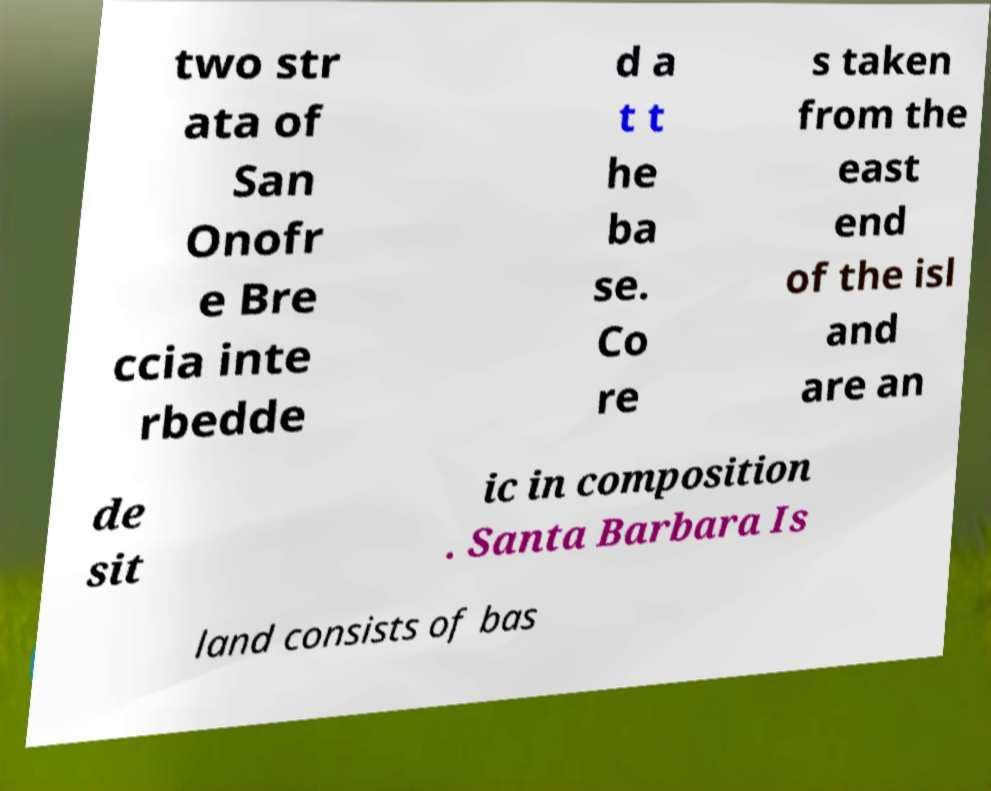For documentation purposes, I need the text within this image transcribed. Could you provide that? two str ata of San Onofr e Bre ccia inte rbedde d a t t he ba se. Co re s taken from the east end of the isl and are an de sit ic in composition . Santa Barbara Is land consists of bas 